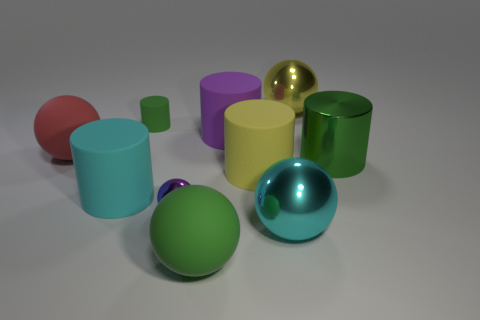Subtract 2 cylinders. How many cylinders are left? 3 Subtract all brown cylinders. Subtract all gray balls. How many cylinders are left? 5 Add 4 cylinders. How many cylinders are left? 9 Add 6 purple matte objects. How many purple matte objects exist? 7 Subtract 0 gray cubes. How many objects are left? 10 Subtract all big balls. Subtract all blocks. How many objects are left? 6 